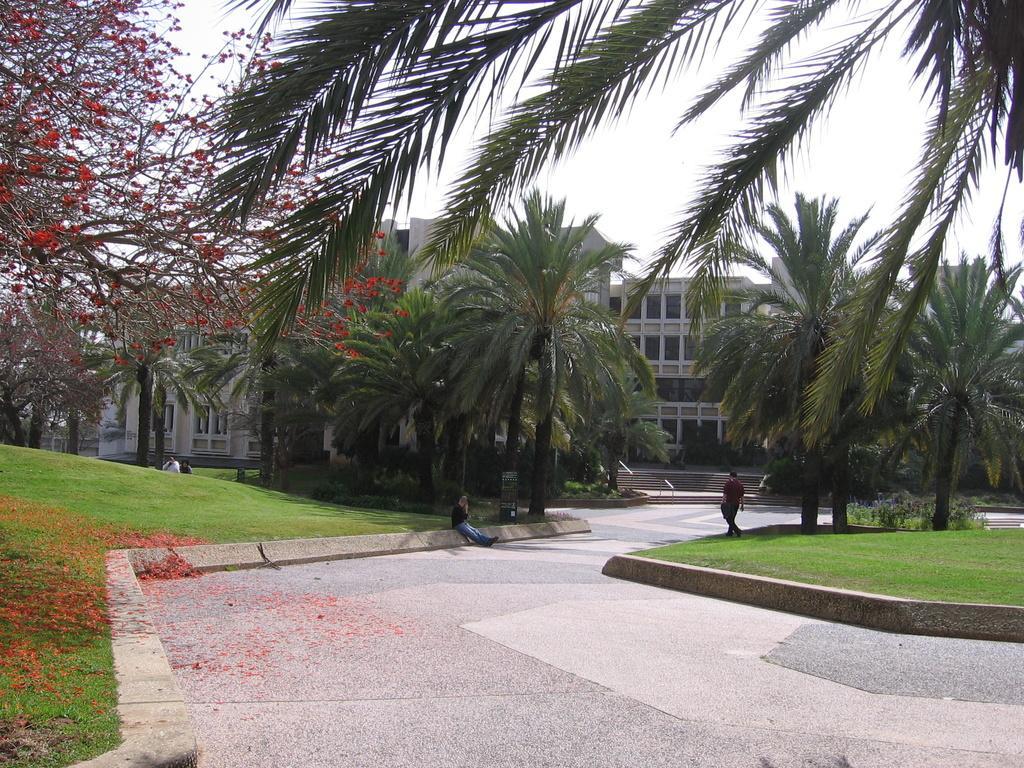In one or two sentences, can you explain what this image depicts? In this image, we can see the walkway, we can see two persons. There are some trees and buildings. We can see the sky. 